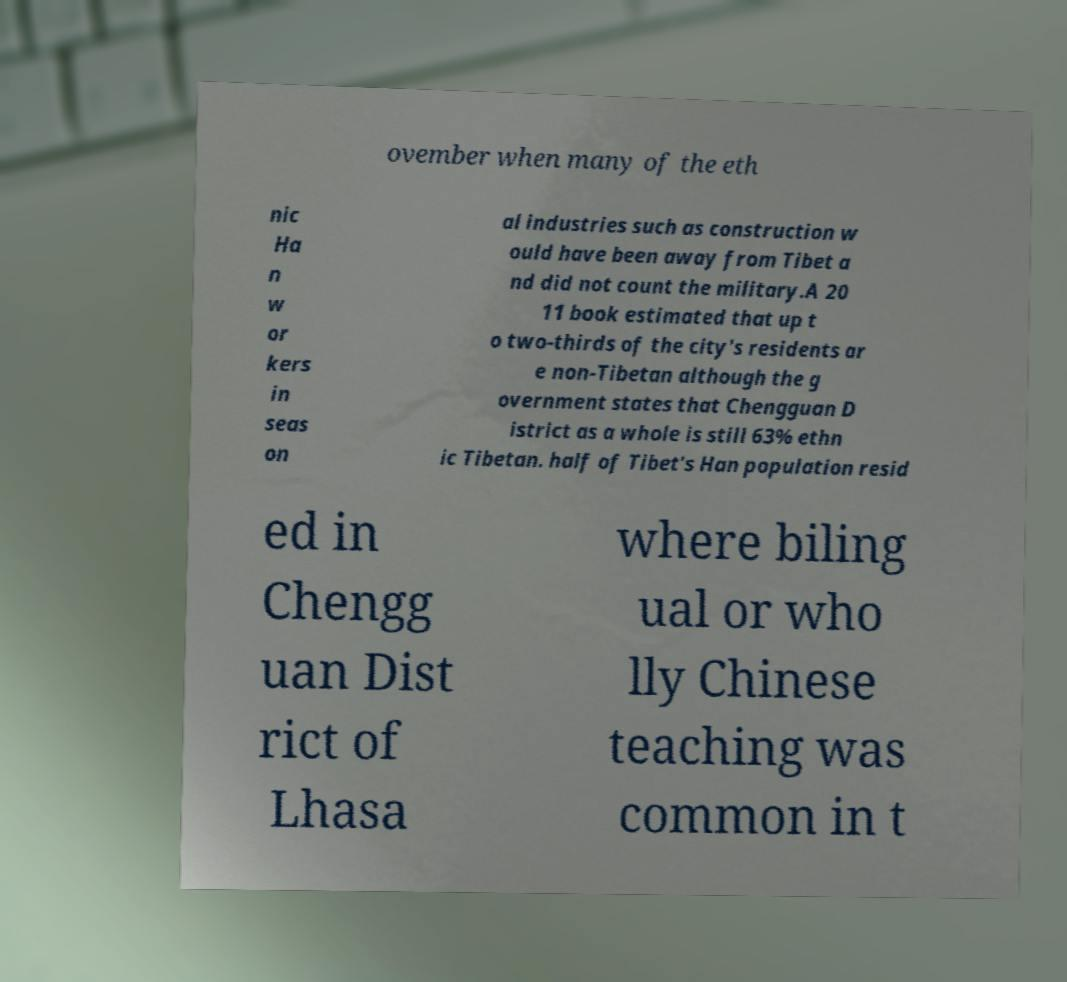Could you extract and type out the text from this image? ovember when many of the eth nic Ha n w or kers in seas on al industries such as construction w ould have been away from Tibet a nd did not count the military.A 20 11 book estimated that up t o two-thirds of the city's residents ar e non-Tibetan although the g overnment states that Chengguan D istrict as a whole is still 63% ethn ic Tibetan. half of Tibet's Han population resid ed in Chengg uan Dist rict of Lhasa where biling ual or who lly Chinese teaching was common in t 